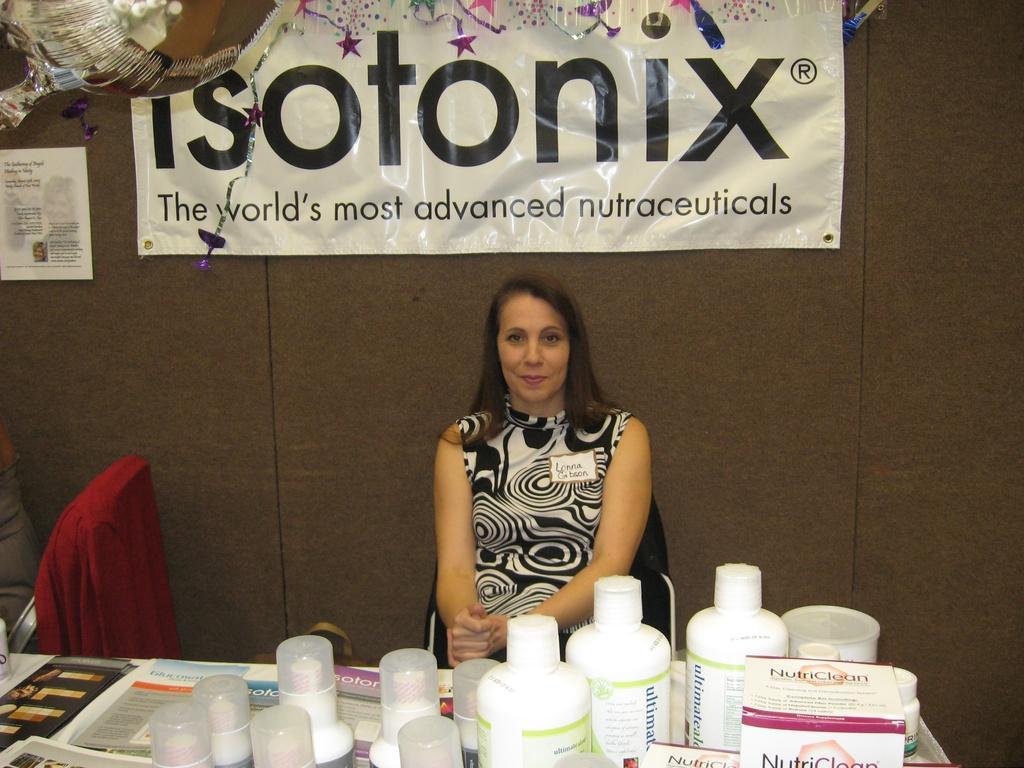In one or two sentences, can you explain what this image depicts? In this Image I see a woman who is sitting on chair and she is smiling. In front of her I see a table on which there are many things. In the background I see the wall and a banner. 